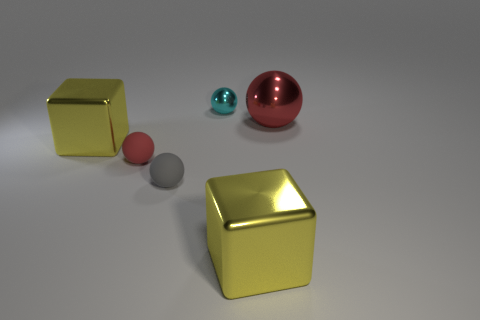How big is the rubber ball that is in front of the red matte ball left of the big metal cube that is in front of the small gray matte object?
Offer a terse response. Small. There is a gray rubber thing that is the same size as the cyan shiny thing; what is its shape?
Make the answer very short. Sphere. How many objects are large metallic blocks on the right side of the small cyan object or large red rubber balls?
Your answer should be compact. 1. There is a large yellow shiny thing on the left side of the red sphere that is to the left of the red metal ball; are there any large metal objects in front of it?
Your response must be concise. Yes. How many cyan spheres are there?
Offer a terse response. 1. How many things are either blocks that are in front of the small cyan ball or spheres that are in front of the cyan ball?
Your answer should be very brief. 5. Does the yellow shiny cube in front of the gray rubber sphere have the same size as the small cyan shiny thing?
Your answer should be compact. No. There is a red shiny thing that is the same shape as the tiny red rubber thing; what is its size?
Provide a succinct answer. Large. There is a gray object that is the same size as the red rubber object; what is it made of?
Make the answer very short. Rubber. There is a gray thing that is the same shape as the small red object; what is it made of?
Provide a succinct answer. Rubber. 